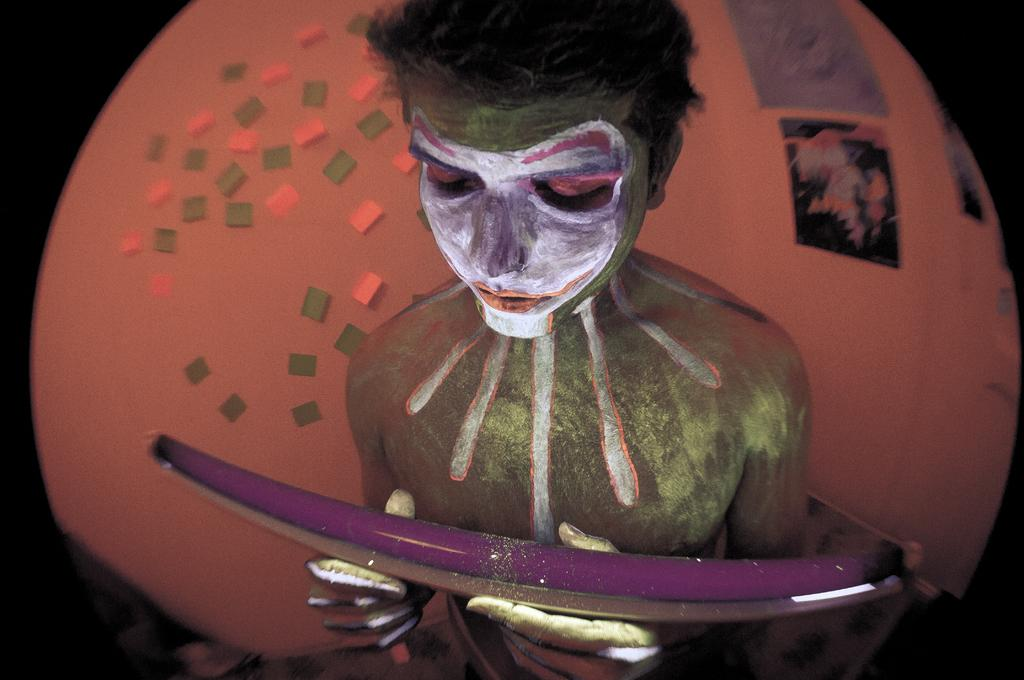What can be seen in the image? There is a person in the image. What is the person wearing? The person is wearing a painting. What is the person holding? The person is holding an object. What is visible on the whiteboard in the image? There are posters and sticky notes on the whiteboard. What type of bell can be heard ringing in the image? There is no bell present in the image, and therefore no sound can be heard. 